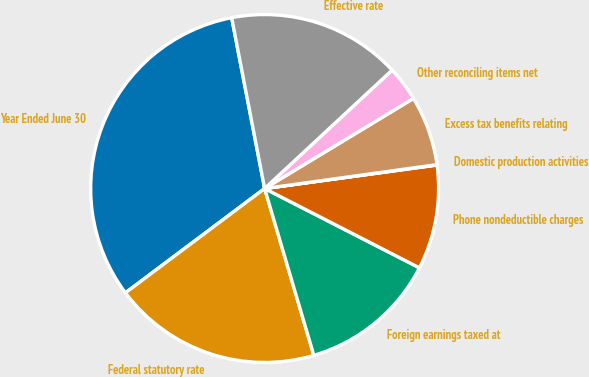Convert chart to OTSL. <chart><loc_0><loc_0><loc_500><loc_500><pie_chart><fcel>Year Ended June 30<fcel>Federal statutory rate<fcel>Foreign earnings taxed at<fcel>Phone nondeductible charges<fcel>Domestic production activities<fcel>Excess tax benefits relating<fcel>Other reconciling items net<fcel>Effective rate<nl><fcel>32.2%<fcel>19.33%<fcel>12.9%<fcel>9.69%<fcel>0.04%<fcel>6.47%<fcel>3.25%<fcel>16.12%<nl></chart> 